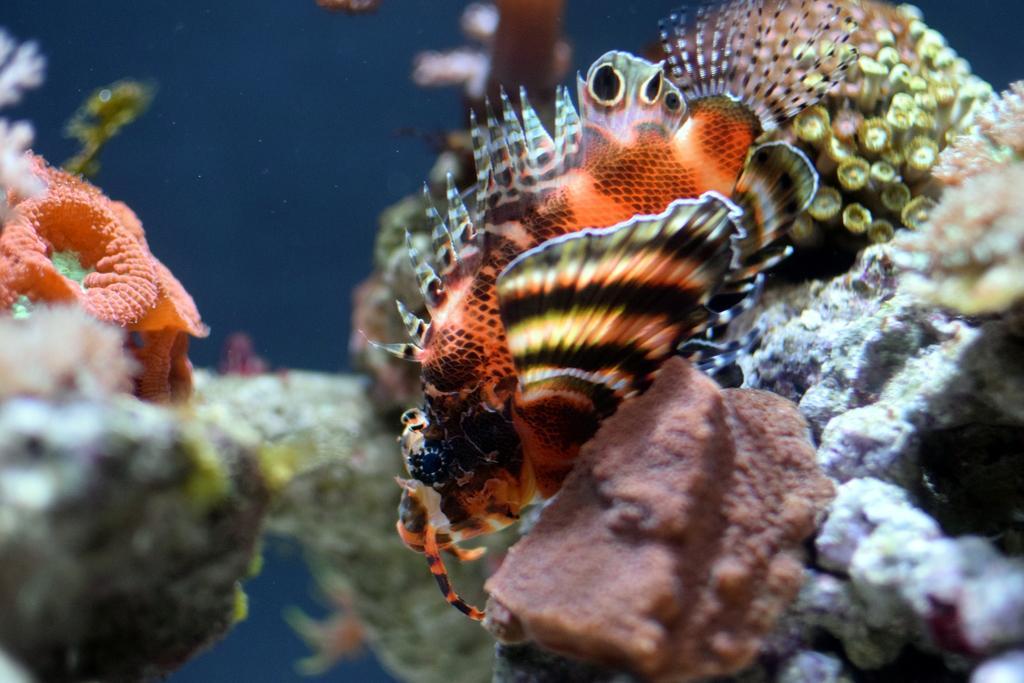In one or two sentences, can you explain what this image depicts? The picture is taken inside the water. In the center of the picture there is a fish. Around the fish there are coral reefs. 